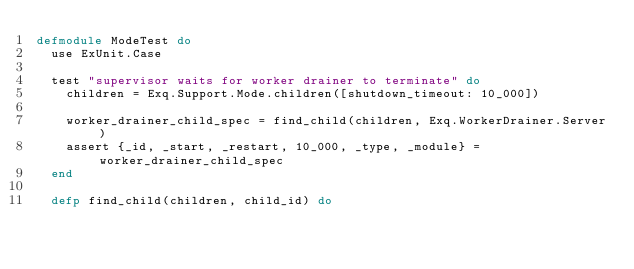<code> <loc_0><loc_0><loc_500><loc_500><_Elixir_>defmodule ModeTest do
  use ExUnit.Case

  test "supervisor waits for worker drainer to terminate" do
    children = Exq.Support.Mode.children([shutdown_timeout: 10_000])

    worker_drainer_child_spec = find_child(children, Exq.WorkerDrainer.Server)
    assert {_id, _start, _restart, 10_000, _type, _module} = worker_drainer_child_spec
  end

  defp find_child(children, child_id) do</code> 